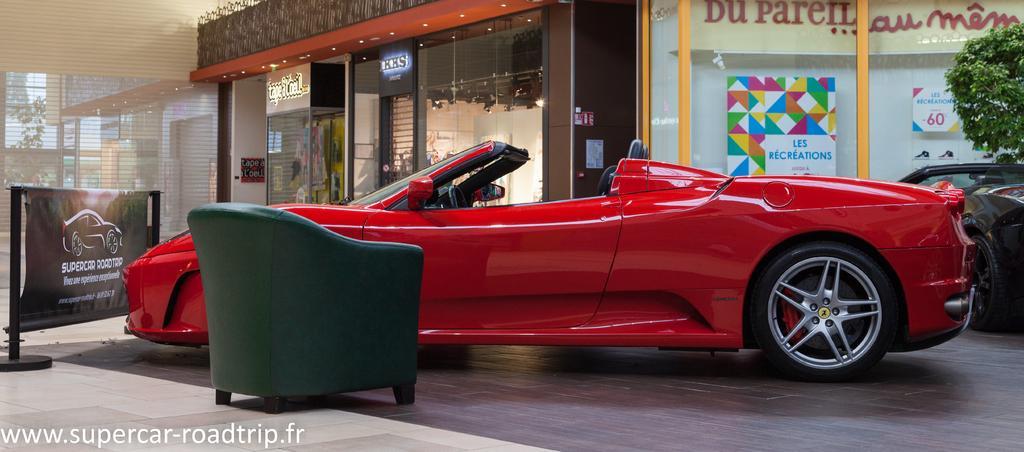In one or two sentences, can you explain what this image depicts? This picture shows couple of cars one is red in color and other one is black in color and we see a chair and a tree on side and and we see a advertisement banner and a store and we see couple of buildings and a tree from the glass and we see couple of posters on the glass. 